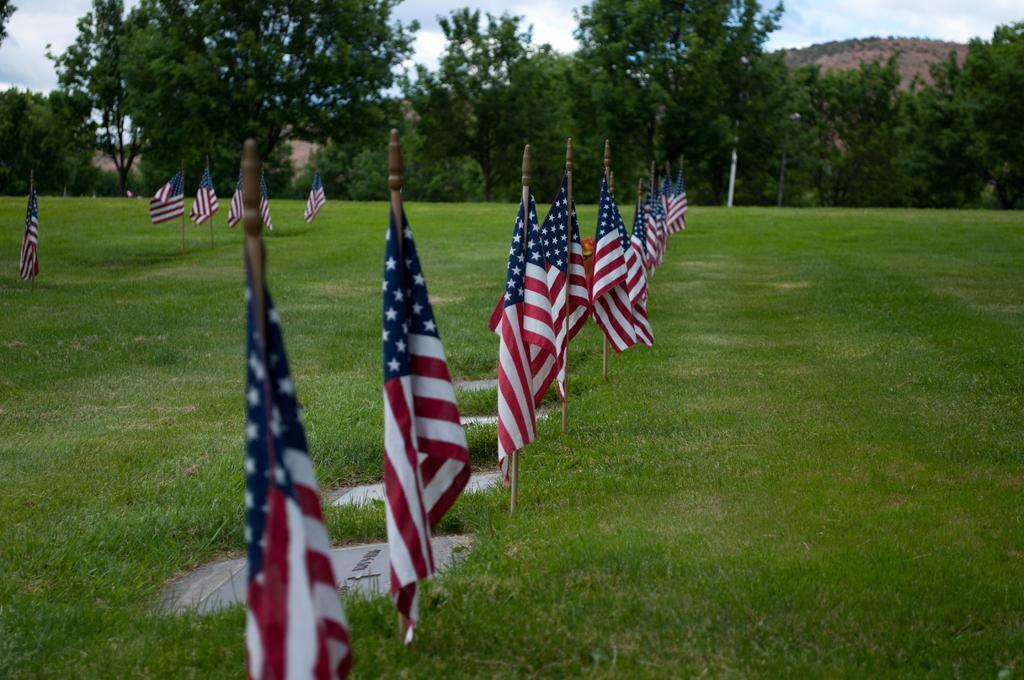What type of surface is visible in the image? There is a ground in the image. What is covering the ground? There is green grass on the ground. What can be seen on poles in the image? There are flags on poles in the image. What type of vegetation is visible in the background of the image? There are trees in the background of the image. What type of geographical feature is visible in the background of the image? There are mountains in the background of the image. What is visible at the top of the image? The sky is visible at the top of the image. Reasoning: Let's think step by step by step in order to produce the conversation. We start by identifying the main surface in the image, which is the ground. Then, we expand the conversation to include the green grass covering the ground, the flags on poles, the trees and mountains in the background, and the sky visible at the top. Each question is designed to elicit a specific detail about the image that is known from the provided facts. Absurd Question/Answer: What type of degree is required to climb the trousers in the image? There are no trousers present in the image, and therefore no climbing or degrees are relevant. 